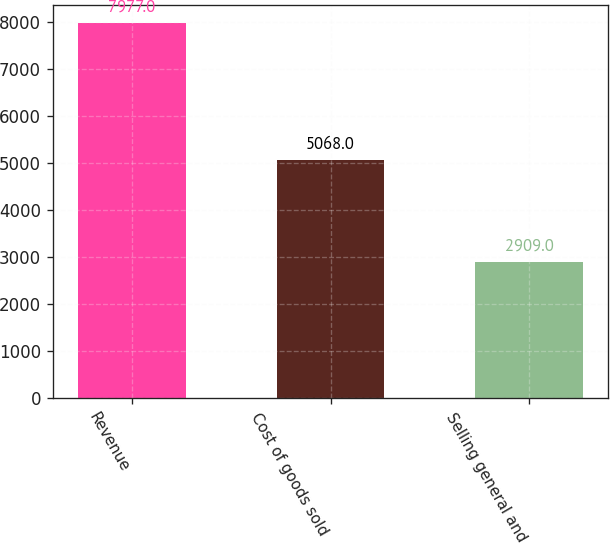<chart> <loc_0><loc_0><loc_500><loc_500><bar_chart><fcel>Revenue<fcel>Cost of goods sold<fcel>Selling general and<nl><fcel>7977<fcel>5068<fcel>2909<nl></chart> 